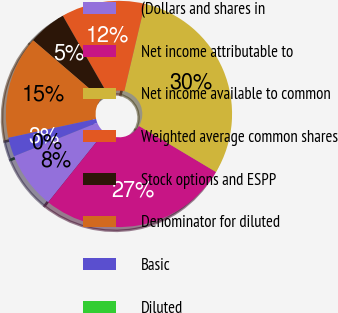<chart> <loc_0><loc_0><loc_500><loc_500><pie_chart><fcel>(Dollars and shares in<fcel>Net income attributable to<fcel>Net income available to common<fcel>Weighted average common shares<fcel>Stock options and ESPP<fcel>Denominator for diluted<fcel>Basic<fcel>Diluted<nl><fcel>8.15%<fcel>27.17%<fcel>29.89%<fcel>11.96%<fcel>5.44%<fcel>14.67%<fcel>2.72%<fcel>0.0%<nl></chart> 